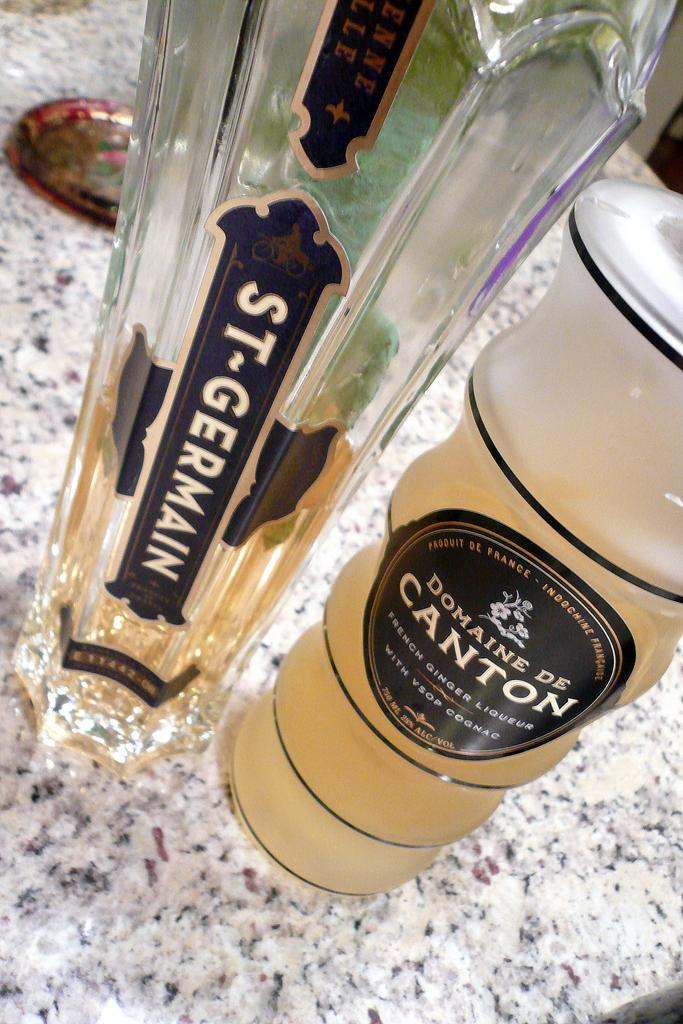<image>
Describe the image concisely. A bottle of St Germain alcohol next to a frosted glass bottle of Domaine De Canton French ginger liqueur with black labels. 